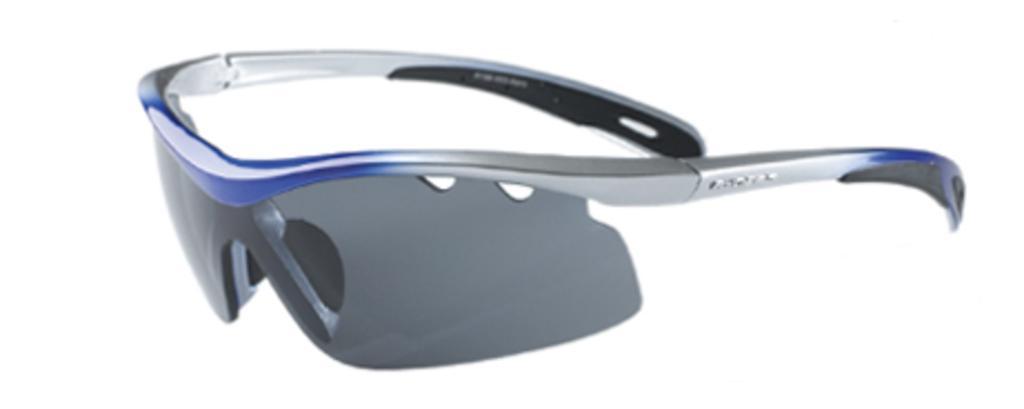Please provide a concise description of this image. In this image we can see goggles. In the background it is white. 